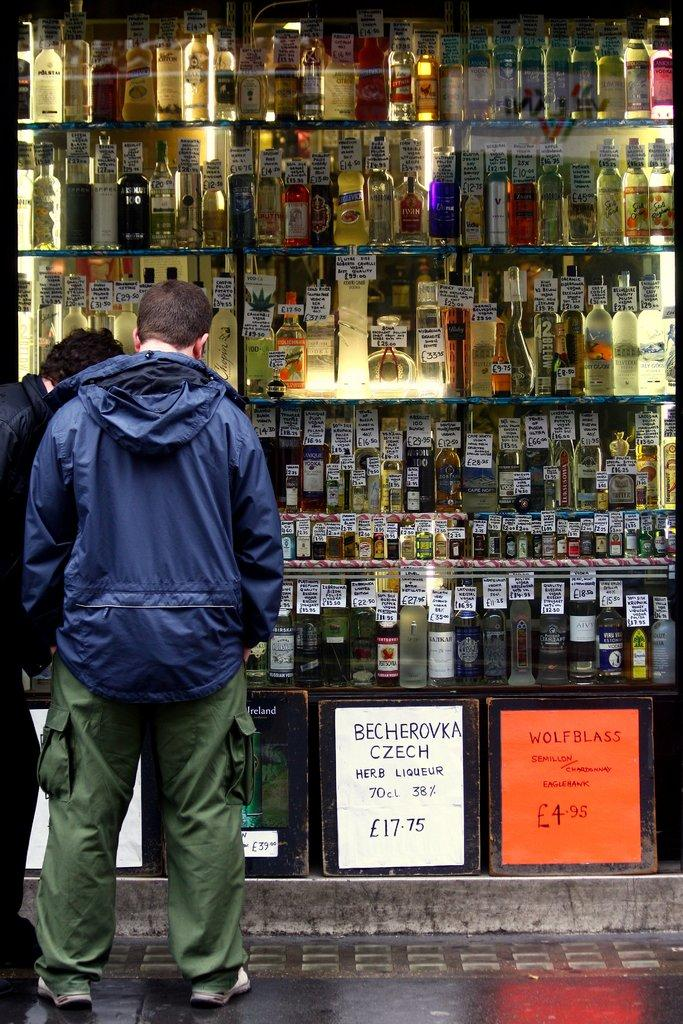<image>
Give a short and clear explanation of the subsequent image. A man is standing in front of a display of bottles of liqueur with signs saying BECHEROVKA CZECH and WOLFBLASS. 